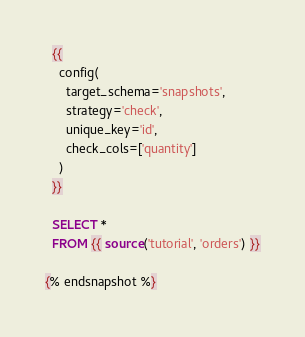<code> <loc_0><loc_0><loc_500><loc_500><_SQL_>  {{
    config(
      target_schema='snapshots',
      strategy='check',
      unique_key='id',
      check_cols=['quantity']
    )
  }}

  SELECT * 
  FROM {{ source('tutorial', 'orders') }}

{% endsnapshot %}</code> 